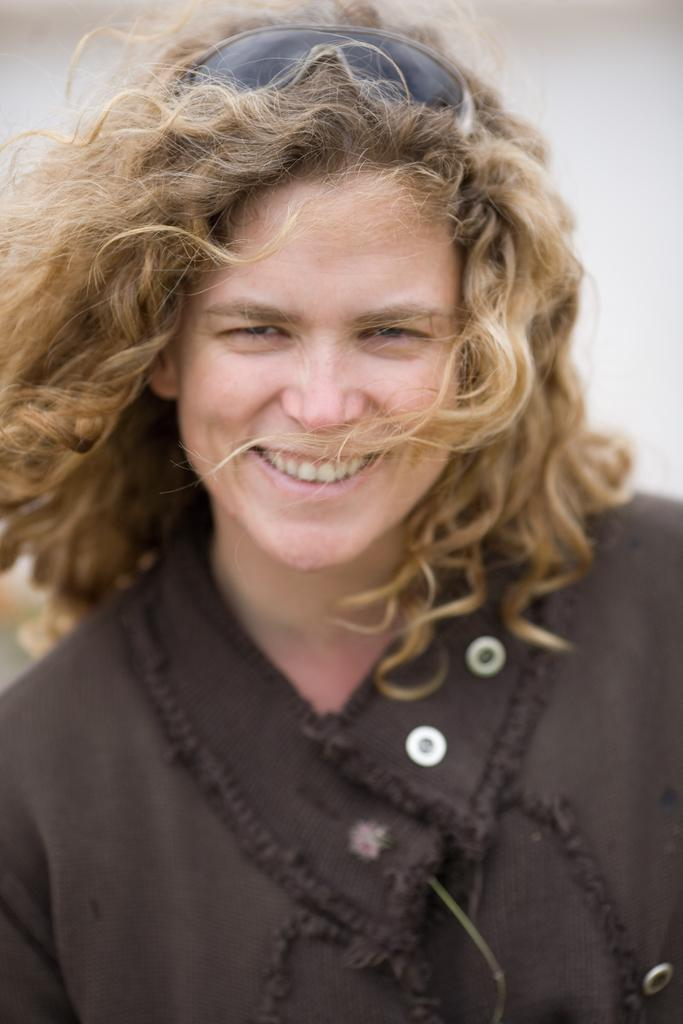What is present in the image? There is a person in the image. What is the person wearing? The person is wearing a brown dress. What color is the background of the image? The background of the image is white. What type of watch is the person wearing in the image? There is no watch visible in the image. What type of vegetable can be seen in the person's hand in the image? There is no vegetable present in the image. 